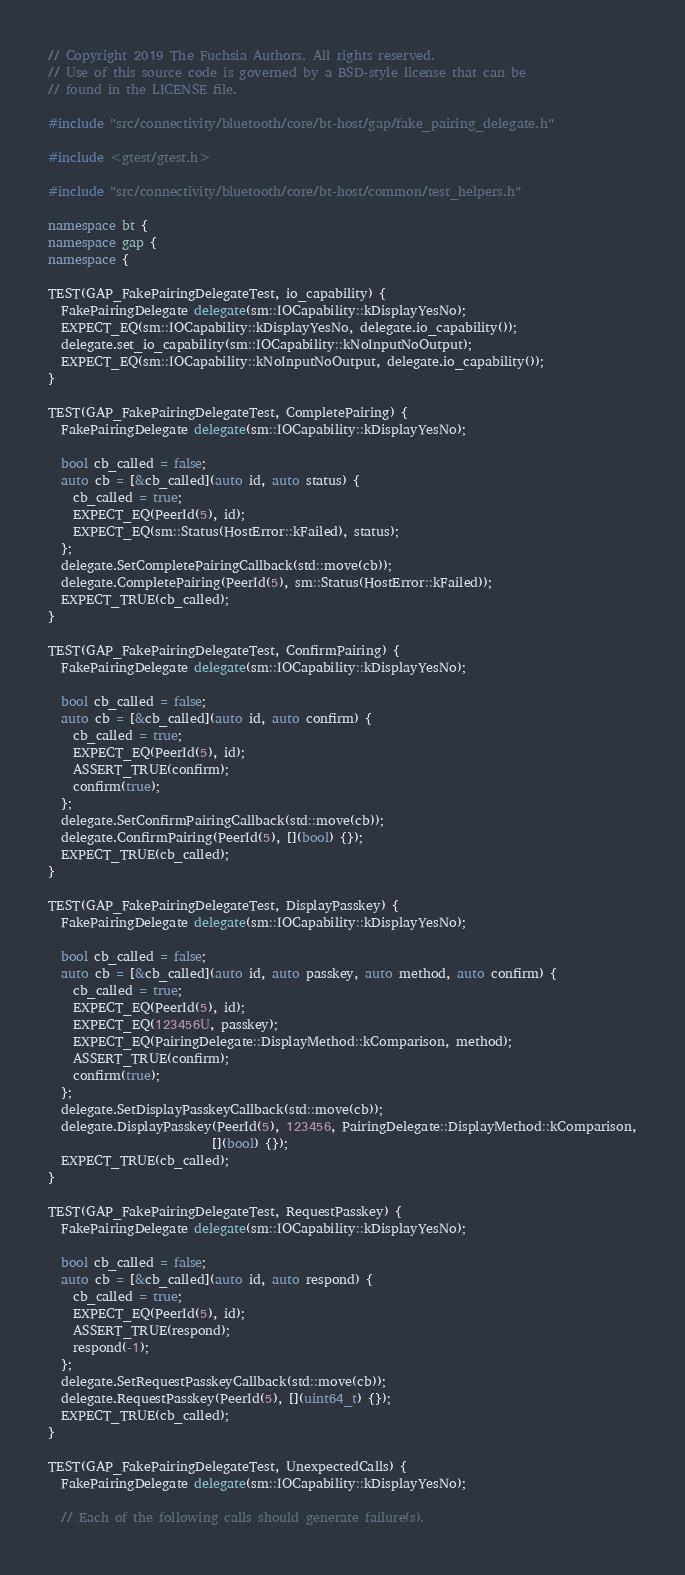<code> <loc_0><loc_0><loc_500><loc_500><_C++_>// Copyright 2019 The Fuchsia Authors. All rights reserved.
// Use of this source code is governed by a BSD-style license that can be
// found in the LICENSE file.

#include "src/connectivity/bluetooth/core/bt-host/gap/fake_pairing_delegate.h"

#include <gtest/gtest.h>

#include "src/connectivity/bluetooth/core/bt-host/common/test_helpers.h"

namespace bt {
namespace gap {
namespace {

TEST(GAP_FakePairingDelegateTest, io_capability) {
  FakePairingDelegate delegate(sm::IOCapability::kDisplayYesNo);
  EXPECT_EQ(sm::IOCapability::kDisplayYesNo, delegate.io_capability());
  delegate.set_io_capability(sm::IOCapability::kNoInputNoOutput);
  EXPECT_EQ(sm::IOCapability::kNoInputNoOutput, delegate.io_capability());
}

TEST(GAP_FakePairingDelegateTest, CompletePairing) {
  FakePairingDelegate delegate(sm::IOCapability::kDisplayYesNo);

  bool cb_called = false;
  auto cb = [&cb_called](auto id, auto status) {
    cb_called = true;
    EXPECT_EQ(PeerId(5), id);
    EXPECT_EQ(sm::Status(HostError::kFailed), status);
  };
  delegate.SetCompletePairingCallback(std::move(cb));
  delegate.CompletePairing(PeerId(5), sm::Status(HostError::kFailed));
  EXPECT_TRUE(cb_called);
}

TEST(GAP_FakePairingDelegateTest, ConfirmPairing) {
  FakePairingDelegate delegate(sm::IOCapability::kDisplayYesNo);

  bool cb_called = false;
  auto cb = [&cb_called](auto id, auto confirm) {
    cb_called = true;
    EXPECT_EQ(PeerId(5), id);
    ASSERT_TRUE(confirm);
    confirm(true);
  };
  delegate.SetConfirmPairingCallback(std::move(cb));
  delegate.ConfirmPairing(PeerId(5), [](bool) {});
  EXPECT_TRUE(cb_called);
}

TEST(GAP_FakePairingDelegateTest, DisplayPasskey) {
  FakePairingDelegate delegate(sm::IOCapability::kDisplayYesNo);

  bool cb_called = false;
  auto cb = [&cb_called](auto id, auto passkey, auto method, auto confirm) {
    cb_called = true;
    EXPECT_EQ(PeerId(5), id);
    EXPECT_EQ(123456U, passkey);
    EXPECT_EQ(PairingDelegate::DisplayMethod::kComparison, method);
    ASSERT_TRUE(confirm);
    confirm(true);
  };
  delegate.SetDisplayPasskeyCallback(std::move(cb));
  delegate.DisplayPasskey(PeerId(5), 123456, PairingDelegate::DisplayMethod::kComparison,
                          [](bool) {});
  EXPECT_TRUE(cb_called);
}

TEST(GAP_FakePairingDelegateTest, RequestPasskey) {
  FakePairingDelegate delegate(sm::IOCapability::kDisplayYesNo);

  bool cb_called = false;
  auto cb = [&cb_called](auto id, auto respond) {
    cb_called = true;
    EXPECT_EQ(PeerId(5), id);
    ASSERT_TRUE(respond);
    respond(-1);
  };
  delegate.SetRequestPasskeyCallback(std::move(cb));
  delegate.RequestPasskey(PeerId(5), [](uint64_t) {});
  EXPECT_TRUE(cb_called);
}

TEST(GAP_FakePairingDelegateTest, UnexpectedCalls) {
  FakePairingDelegate delegate(sm::IOCapability::kDisplayYesNo);

  // Each of the following calls should generate failure(s).</code> 